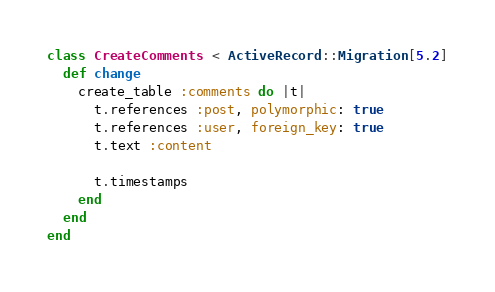<code> <loc_0><loc_0><loc_500><loc_500><_Ruby_>class CreateComments < ActiveRecord::Migration[5.2]
  def change
    create_table :comments do |t|
      t.references :post, polymorphic: true
      t.references :user, foreign_key: true
      t.text :content

      t.timestamps
    end
  end
end
</code> 